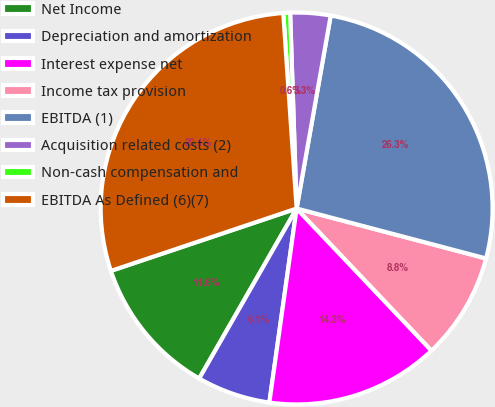Convert chart to OTSL. <chart><loc_0><loc_0><loc_500><loc_500><pie_chart><fcel>Net Income<fcel>Depreciation and amortization<fcel>Interest expense net<fcel>Income tax provision<fcel>EBITDA (1)<fcel>Acquisition related costs (2)<fcel>Non-cash compensation and<fcel>EBITDA As Defined (6)(7)<nl><fcel>11.56%<fcel>6.06%<fcel>14.31%<fcel>8.81%<fcel>26.32%<fcel>3.31%<fcel>0.56%<fcel>29.07%<nl></chart> 